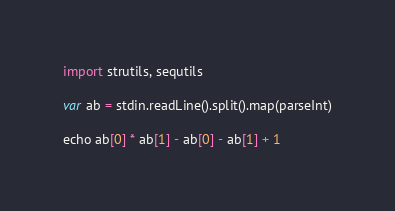<code> <loc_0><loc_0><loc_500><loc_500><_Nim_>import strutils, sequtils

var ab = stdin.readLine().split().map(parseInt)

echo ab[0] * ab[1] - ab[0] - ab[1] + 1</code> 